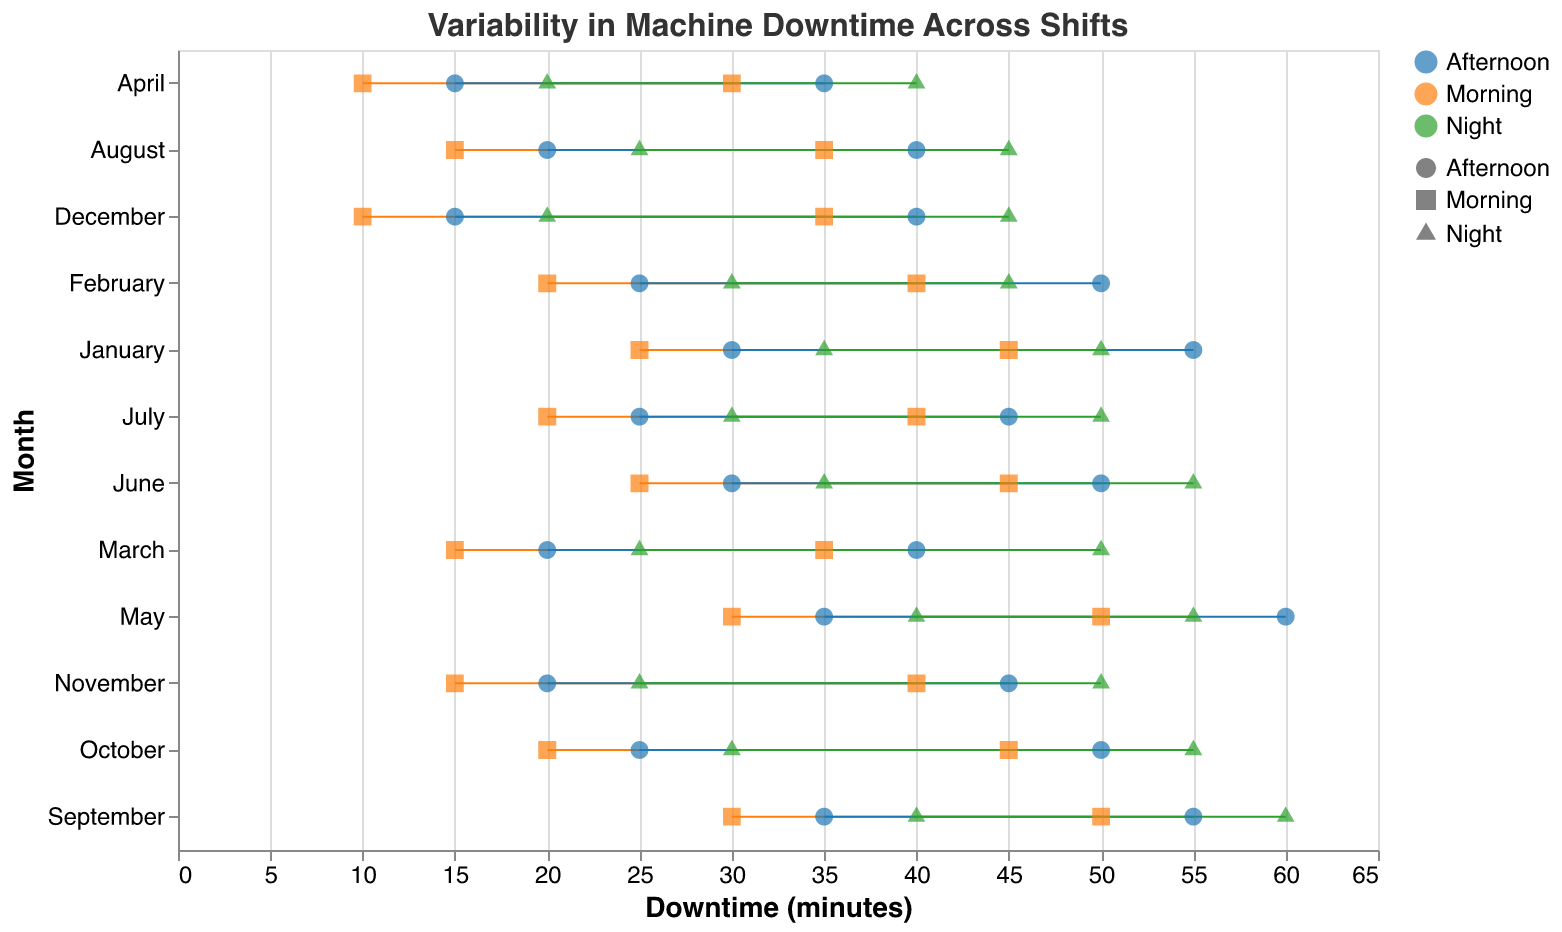How many months show downtime data on the plot? The y-axis of the plot lists all the different months (January through December). By counting these, it’s evident there are 12 months displayed.
Answer: 12 Which shift had the highest maximum downtime in May? In May, the plot shows the ranges for Morning, Afternoon, and Night shifts. The maximum downtime for the Night shift reaches 55, 60 for the Afternoon shift, and 50 for the Morning shift. The Afternoon shift has the highest maximum downtime.
Answer: Afternoon During which month did the Morning shift have the lowest minimum downtime? By looking at the data points for the Morning shift across all months, the minimum down time of 10 minutes occurs in April and December. By evaluating further on the plot, 10 minutes for the Morning shift occurred in April and December.
Answer: April, December What was the range of downtime for the Night shift in March? The plot shows the minimum and maximum downtimes for the Night shift in March as 25 and 50 minutes respectively. Subtracting these gives a range of 25 minutes.
Answer: 25 minutes Which shift generally exhibits higher downtime, Night or Morning? By comparing the ranges of downtimes for Morning and Night shifts across different months consistently shows that Night shifts generally have higher downtime ranges (larger values and broader ranges) compared to Morning shifts.
Answer: Night Between which two months is there the largest increase in maximum downtime for the Afternoon shift? Examine the maximum downtime values for the Afternoon shift. The largest spike happens between April to May, where the downtime increases from 35 to 60 minutes, an increase of 25 minutes.
Answer: April to May What is the average of the minimum downtime across all months for the Morning shift? Sum the minimum downtime values for Morning shifts from January to December and then divide by the number of months. The total = 25+20+15+10+30+25+20+15+30+20+15+10 = 230. The number of months is 12, so the average is 230/12 ≈ 19.2 minutes.
Answer: 19.2 minutes How does the maximum downtime for September compare between Morning and Afternoon shifts? For September, the maximum downtime for the Morning shift is 50 minutes and for the Afternoon shift is 55 minutes. The Afternoon shift is higher.
Answer: Afternoon shift is higher Which month shows the least variability in downtime across all shifts? To find the least variability, examine the ranges (difference between min and max downtime) for each month. In April, ranges are Morning: 20, Afternoon: 20, Night: 20. April shows consistent variability across all shifts, each having a range of 20 minutes.
Answer: April Which month has the highest average of maximum downtimes across all shifts? Sum the maximum downtimes for all shifts for each month and divide by the number of shifts (3): 
- For May: Morning: 50, Afternoon: 60, Night: 55. Sum = 165, Average = 165/3 ≈ 55.
May has an average maximum downtime of about 55 for all shifts.
Answer: May 